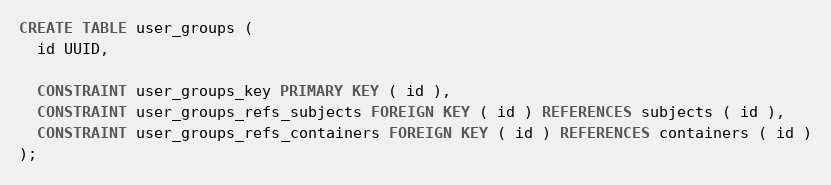Convert code to text. <code><loc_0><loc_0><loc_500><loc_500><_SQL_>CREATE TABLE user_groups (
  id UUID,
  
  CONSTRAINT user_groups_key PRIMARY KEY ( id ),
  CONSTRAINT user_groups_refs_subjects FOREIGN KEY ( id ) REFERENCES subjects ( id ),
  CONSTRAINT user_groups_refs_containers FOREIGN KEY ( id ) REFERENCES containers ( id )
);
</code> 